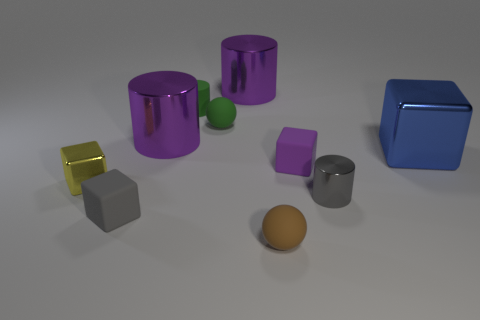Subtract 1 blocks. How many blocks are left? 3 Subtract all cubes. How many objects are left? 6 Add 4 big blue shiny blocks. How many big blue shiny blocks are left? 5 Add 7 small gray cubes. How many small gray cubes exist? 8 Subtract 1 green balls. How many objects are left? 9 Subtract all large objects. Subtract all tiny gray objects. How many objects are left? 5 